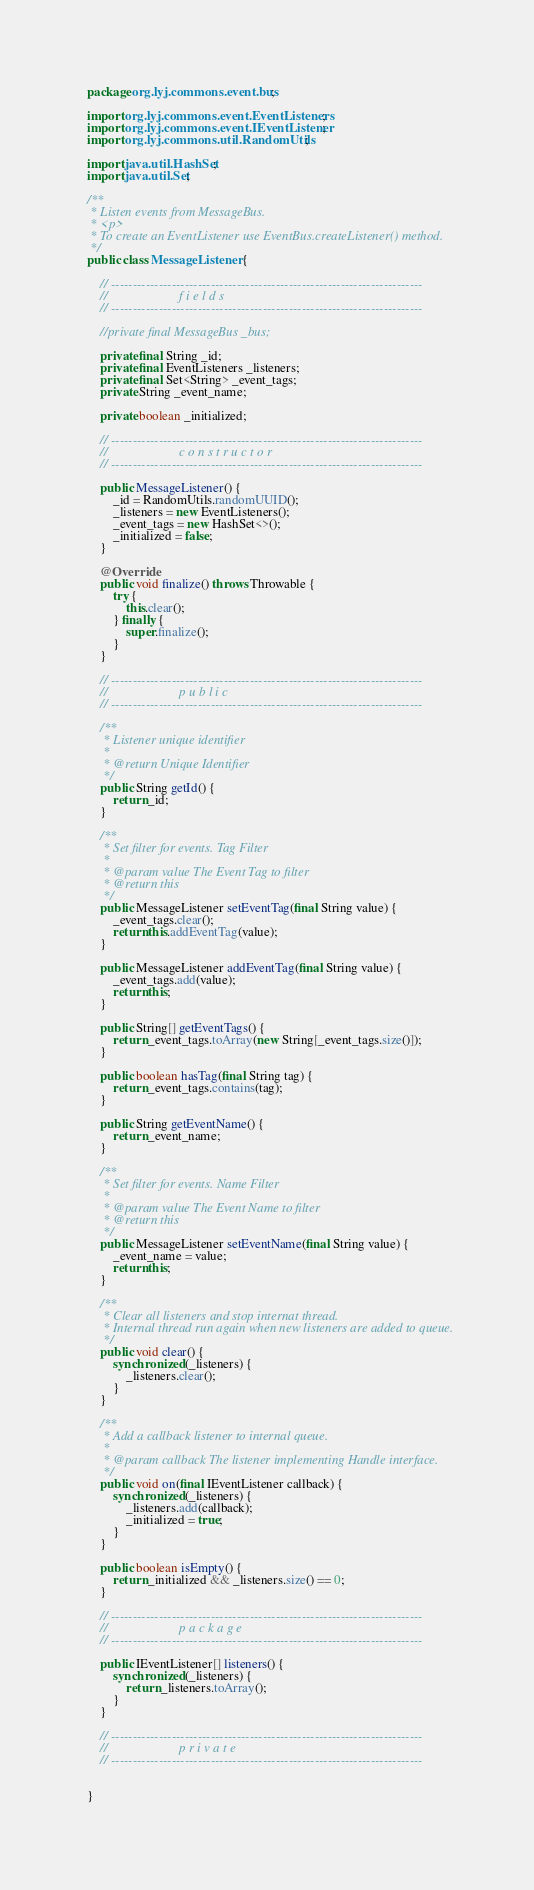Convert code to text. <code><loc_0><loc_0><loc_500><loc_500><_Java_>package org.lyj.commons.event.bus;

import org.lyj.commons.event.EventListeners;
import org.lyj.commons.event.IEventListener;
import org.lyj.commons.util.RandomUtils;

import java.util.HashSet;
import java.util.Set;

/**
 * Listen events from MessageBus.
 * <p>
 * To create an EventListener use EventBus.createListener() method.
 */
public class MessageListener {

    // ------------------------------------------------------------------------
    //                      f i e l d s
    // ------------------------------------------------------------------------

    //private final MessageBus _bus;

    private final String _id;
    private final EventListeners _listeners;
    private final Set<String> _event_tags;
    private String _event_name;

    private boolean _initialized;

    // ------------------------------------------------------------------------
    //                      c o n s t r u c t o r
    // ------------------------------------------------------------------------

    public MessageListener() {
        _id = RandomUtils.randomUUID();
        _listeners = new EventListeners();
        _event_tags = new HashSet<>();
        _initialized = false;
    }

    @Override
    public void finalize() throws Throwable {
        try {
            this.clear();
        } finally {
            super.finalize();
        }
    }

    // ------------------------------------------------------------------------
    //                      p u b l i c
    // ------------------------------------------------------------------------

    /**
     * Listener unique identifier
     *
     * @return Unique Identifier
     */
    public String getId() {
        return _id;
    }

    /**
     * Set filter for events. Tag Filter
     *
     * @param value The Event Tag to filter
     * @return this
     */
    public MessageListener setEventTag(final String value) {
        _event_tags.clear();
        return this.addEventTag(value);
    }

    public MessageListener addEventTag(final String value) {
        _event_tags.add(value);
        return this;
    }

    public String[] getEventTags() {
        return _event_tags.toArray(new String[_event_tags.size()]);
    }

    public boolean hasTag(final String tag) {
        return _event_tags.contains(tag);
    }

    public String getEventName() {
        return _event_name;
    }

    /**
     * Set filter for events. Name Filter
     *
     * @param value The Event Name to filter
     * @return this
     */
    public MessageListener setEventName(final String value) {
        _event_name = value;
        return this;
    }

    /**
     * Clear all listeners and stop internat thread.
     * Internal thread run again when new listeners are added to queue.
     */
    public void clear() {
        synchronized (_listeners) {
            _listeners.clear();
        }
    }

    /**
     * Add a callback listener to internal queue.
     *
     * @param callback The listener implementing Handle interface.
     */
    public void on(final IEventListener callback) {
        synchronized (_listeners) {
            _listeners.add(callback);
            _initialized = true;
        }
    }

    public boolean isEmpty() {
        return _initialized && _listeners.size() == 0;
    }

    // ------------------------------------------------------------------------
    //                      p a c k a g e
    // ------------------------------------------------------------------------

    public IEventListener[] listeners() {
        synchronized (_listeners) {
            return _listeners.toArray();
        }
    }

    // ------------------------------------------------------------------------
    //                      p r i v a t e
    // ------------------------------------------------------------------------


}
</code> 